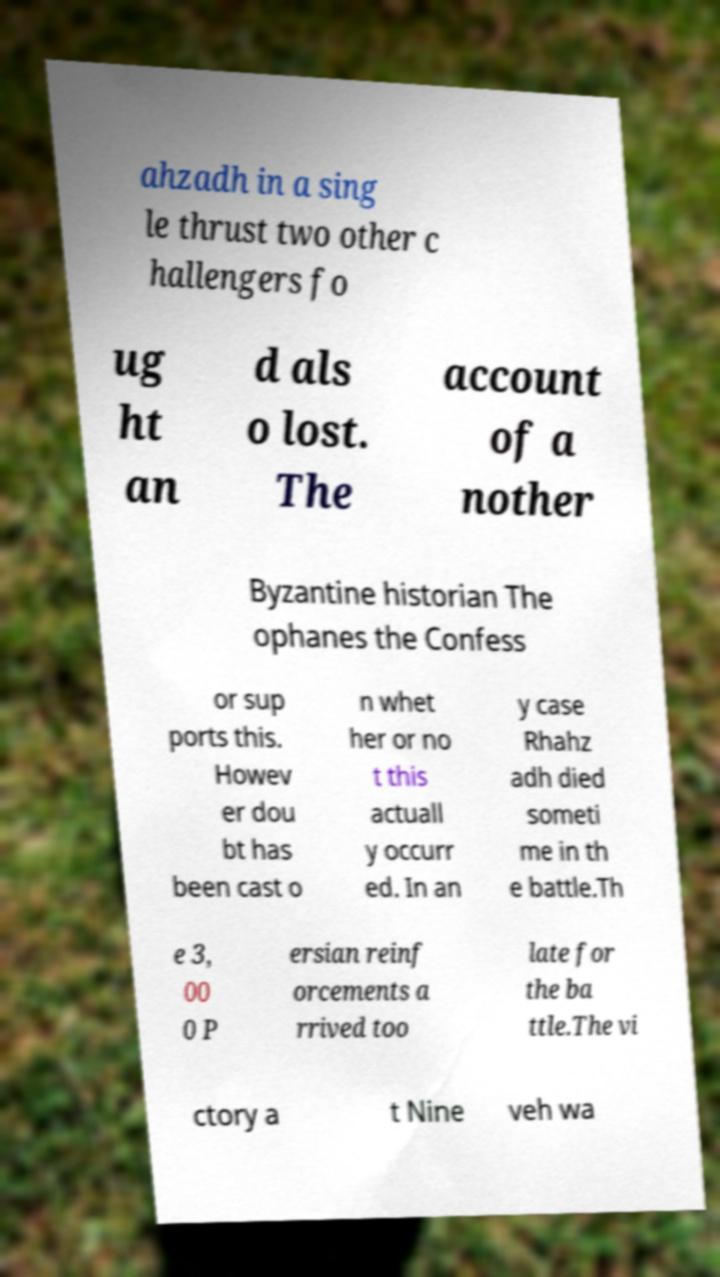For documentation purposes, I need the text within this image transcribed. Could you provide that? ahzadh in a sing le thrust two other c hallengers fo ug ht an d als o lost. The account of a nother Byzantine historian The ophanes the Confess or sup ports this. Howev er dou bt has been cast o n whet her or no t this actuall y occurr ed. In an y case Rhahz adh died someti me in th e battle.Th e 3, 00 0 P ersian reinf orcements a rrived too late for the ba ttle.The vi ctory a t Nine veh wa 